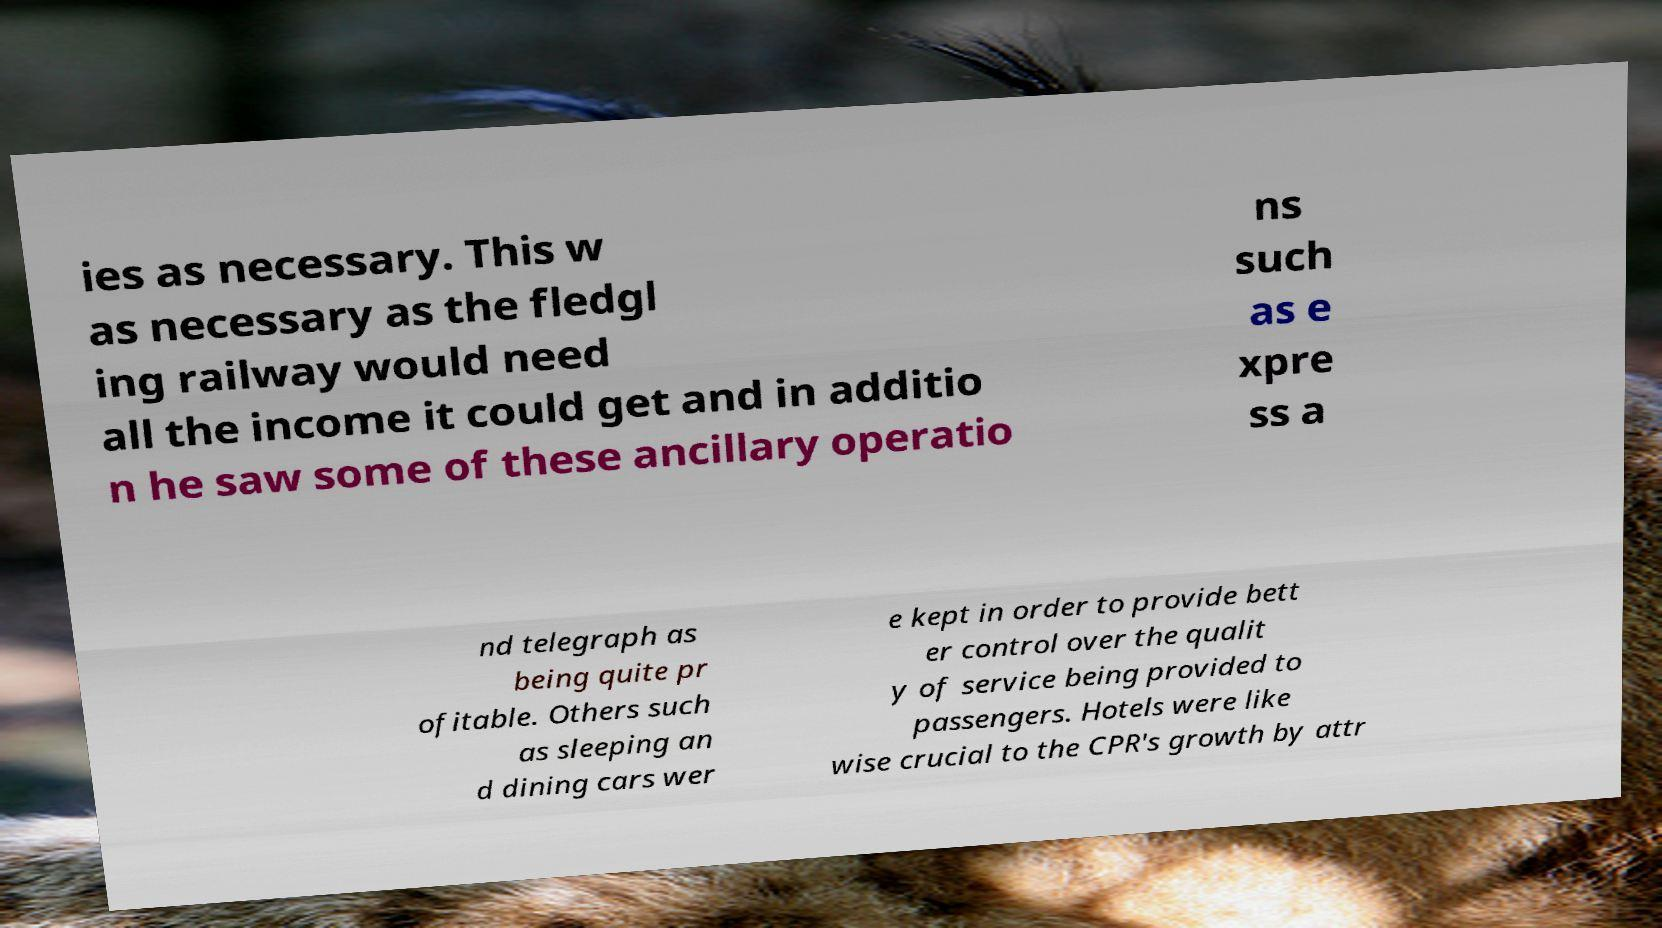Can you accurately transcribe the text from the provided image for me? ies as necessary. This w as necessary as the fledgl ing railway would need all the income it could get and in additio n he saw some of these ancillary operatio ns such as e xpre ss a nd telegraph as being quite pr ofitable. Others such as sleeping an d dining cars wer e kept in order to provide bett er control over the qualit y of service being provided to passengers. Hotels were like wise crucial to the CPR's growth by attr 